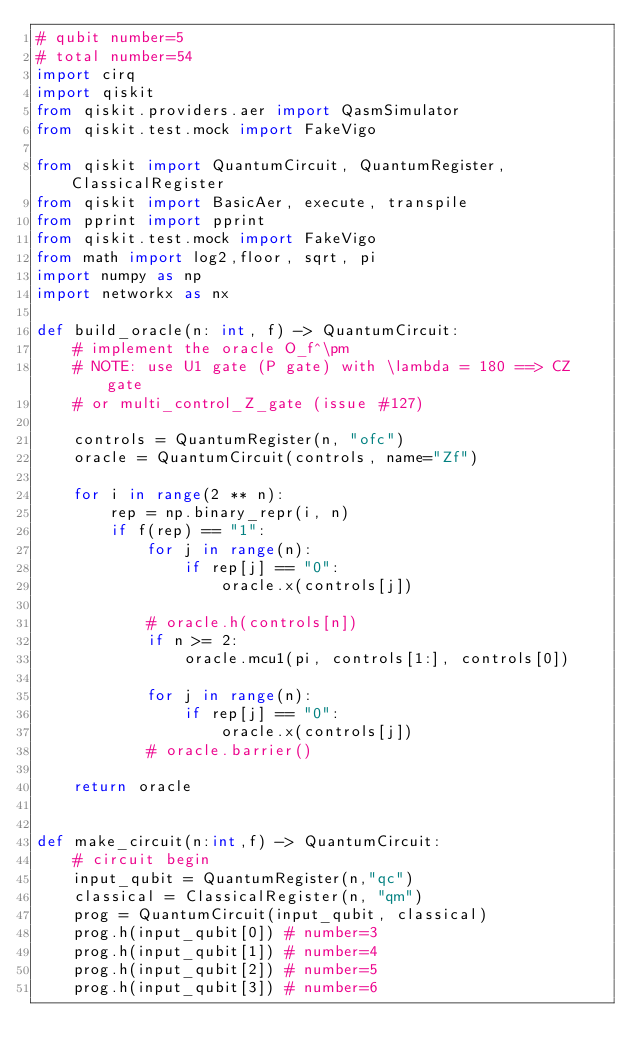Convert code to text. <code><loc_0><loc_0><loc_500><loc_500><_Python_># qubit number=5
# total number=54
import cirq
import qiskit
from qiskit.providers.aer import QasmSimulator
from qiskit.test.mock import FakeVigo

from qiskit import QuantumCircuit, QuantumRegister, ClassicalRegister
from qiskit import BasicAer, execute, transpile
from pprint import pprint
from qiskit.test.mock import FakeVigo
from math import log2,floor, sqrt, pi
import numpy as np
import networkx as nx

def build_oracle(n: int, f) -> QuantumCircuit:
    # implement the oracle O_f^\pm
    # NOTE: use U1 gate (P gate) with \lambda = 180 ==> CZ gate
    # or multi_control_Z_gate (issue #127)

    controls = QuantumRegister(n, "ofc")
    oracle = QuantumCircuit(controls, name="Zf")

    for i in range(2 ** n):
        rep = np.binary_repr(i, n)
        if f(rep) == "1":
            for j in range(n):
                if rep[j] == "0":
                    oracle.x(controls[j])

            # oracle.h(controls[n])
            if n >= 2:
                oracle.mcu1(pi, controls[1:], controls[0])

            for j in range(n):
                if rep[j] == "0":
                    oracle.x(controls[j])
            # oracle.barrier()

    return oracle


def make_circuit(n:int,f) -> QuantumCircuit:
    # circuit begin
    input_qubit = QuantumRegister(n,"qc")
    classical = ClassicalRegister(n, "qm")
    prog = QuantumCircuit(input_qubit, classical)
    prog.h(input_qubit[0]) # number=3
    prog.h(input_qubit[1]) # number=4
    prog.h(input_qubit[2]) # number=5
    prog.h(input_qubit[3]) # number=6</code> 